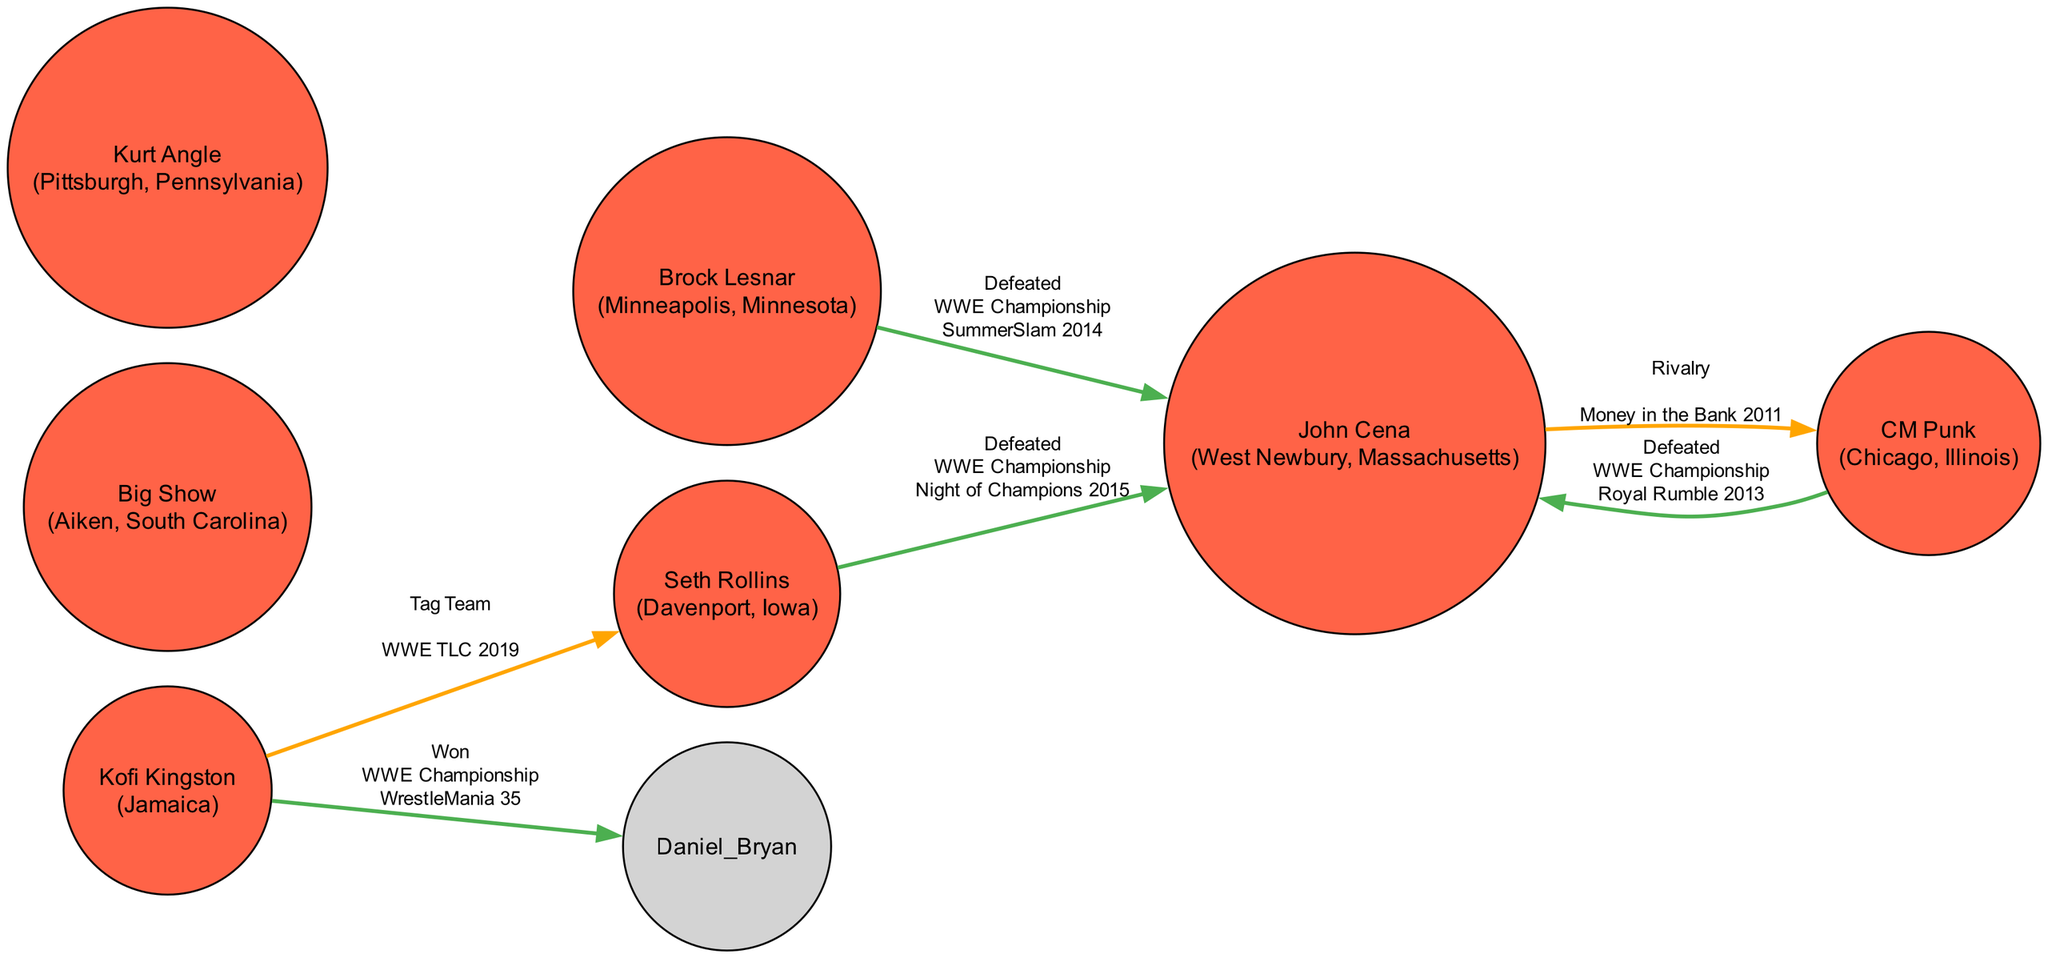What is the total number of wrestlers from New York in the diagram? The diagram currently contains information about wrestlers from various states, but there are no wrestlers specifically listed as hailing from New York. The node data does not include any wrestler with New York as their hometown.
Answer: 0 Who did Brock Lesnar defeat to win the WWE Championship? The edge from Brock Lesnar to John Cena with the label "Defeated" indicates that he defeated John Cena to win the WWE Championship at SummerSlam 2014. The title change is also mentioned.
Answer: John Cena Which wrestler has a rivalry with CM Punk? The edge from John Cena to CM Punk marked as "Rivalry" shows the connection between them, indicating John Cena is in rivalry with CM Punk, highlighted during the Money in the Bank 2011 event.
Answer: John Cena What was the event where Kofi Kingston won the WWE Championship? The edge from Kofi Kingston to Daniel Bryan labeled as "Won" specifies that Kofi Kingston won the WWE Championship at WrestleMania 35. The title change is relevant here.
Answer: WrestleMania 35 How many total edges are in the diagram? By counting each directed edge in the diagram data, we identify a total of six connections, showing the relationships between wrestlers, including defeats, rivalries, and tag team events.
Answer: 6 What is the title change associated with Seth Rollins defeating John Cena? The edge from Seth Rollins to John Cena indicates that this match resulted in a title change, specifically the WWE Championship, as noted on the edge data under "title_change".
Answer: WWE Championship Who is involved in a tag team match with Kofi Kingston? The edge labeled "Tag Team" from Kofi Kingston to Seth Rollins indicates that Seth Rollins is the wrestler involved in a tag team match alongside Kofi Kingston.
Answer: Seth Rollins What color represents wrestlers from New York in the diagram? The diagram uses a specific color scheme where wrestlers from New York are denoted using the color #1E90FF. However, since there are no wrestlers from New York present in the data, this color will not appear in the diagram.
Answer: #1E90FF Which event featured CM Punk defeating John Cena for the WWE Championship? The edge shows that CM Punk defeated John Cena for the WWE Championship at the Royal Rumble 2013, which is noted in the edge data.
Answer: Royal Rumble 2013 